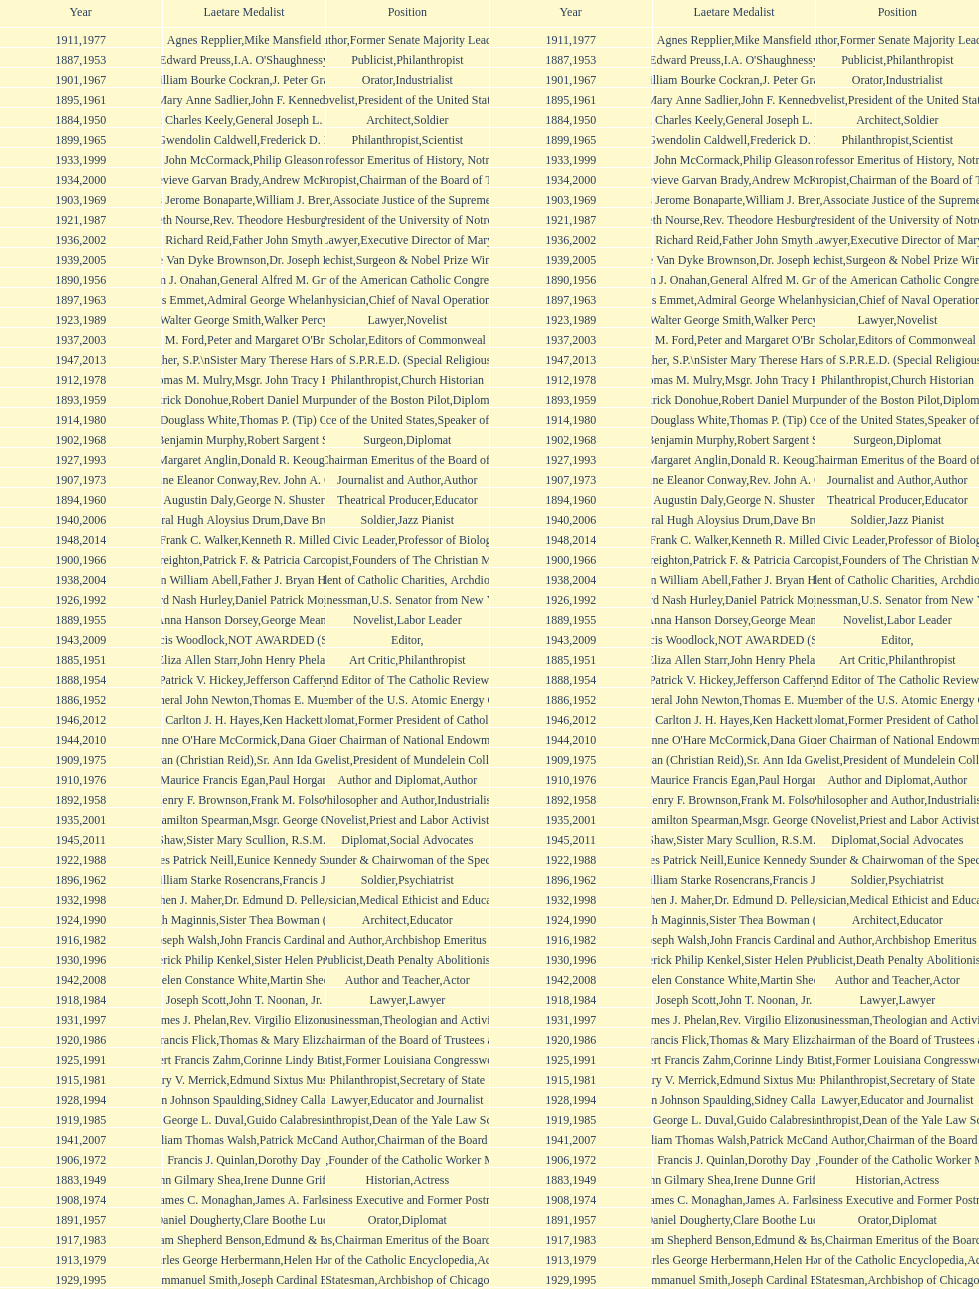Who won the medal after thomas e. murray in 1952? I.A. O'Shaughnessy. 